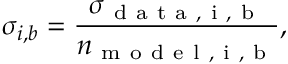Convert formula to latex. <formula><loc_0><loc_0><loc_500><loc_500>\sigma _ { i , b } = \frac { \sigma _ { d a t a , i , b } } { n _ { m o d e l , i , b } } ,</formula> 